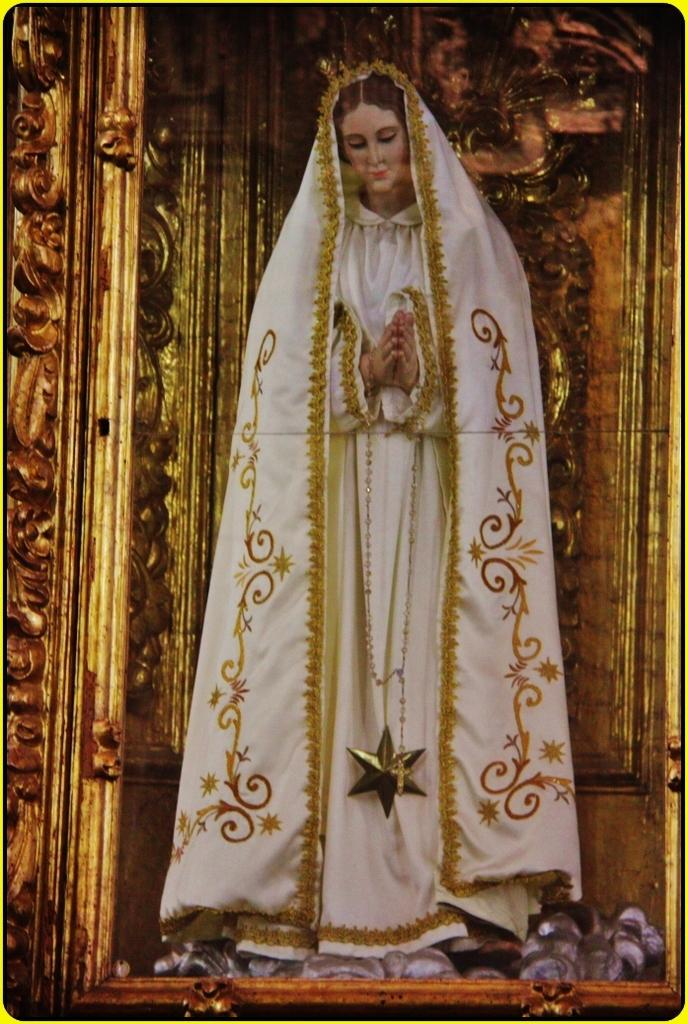What is the main subject in the center of the image? There is a statue in the center of the image. What can be seen in the background of the image? There is a golden color frame in the background of the image. How many boats are visible in the image? There are no boats present in the image. What type of fang can be seen in the image? There is no fang present in the image. 